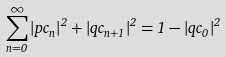<formula> <loc_0><loc_0><loc_500><loc_500>\sum _ { n = 0 } ^ { \infty } \left | p c _ { n } \right | ^ { 2 } + \left | q c _ { n + 1 } \right | ^ { 2 } = 1 - \left | q c _ { 0 } \right | ^ { 2 }</formula> 